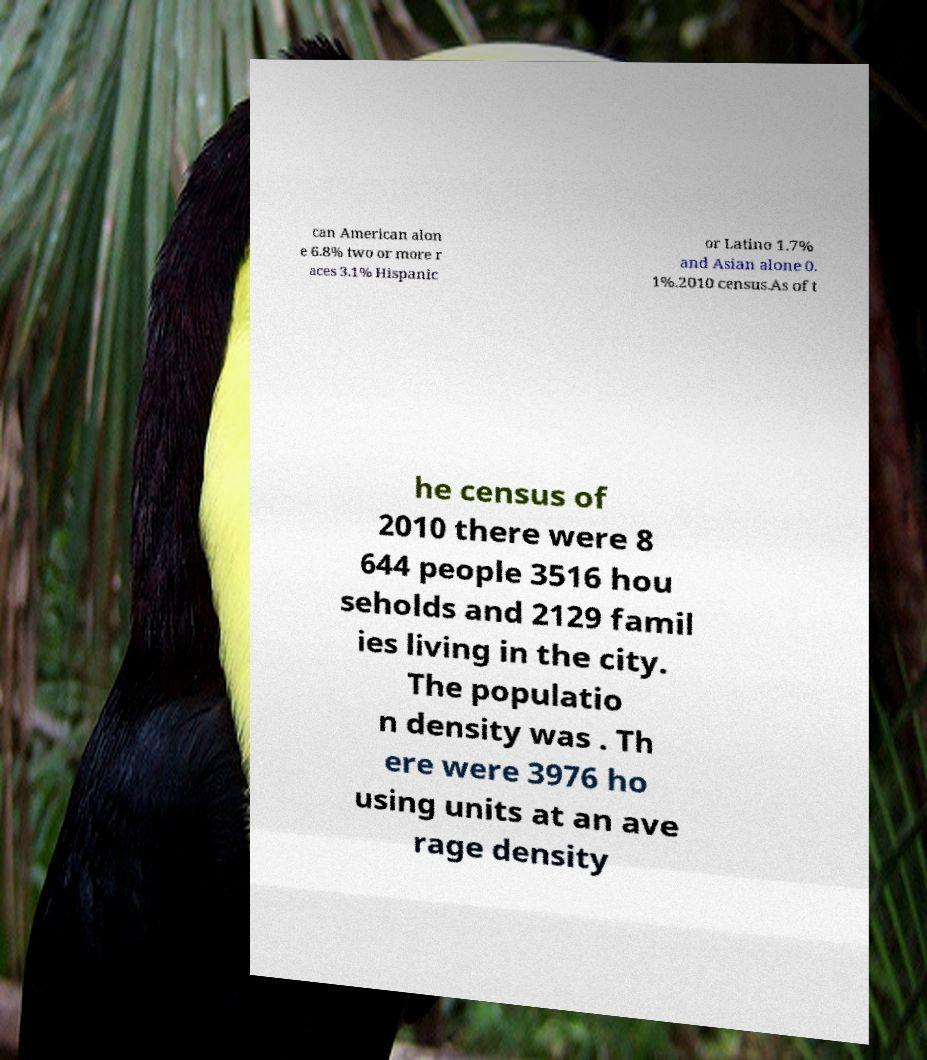Could you extract and type out the text from this image? can American alon e 6.8% two or more r aces 3.1% Hispanic or Latino 1.7% and Asian alone 0. 1%.2010 census.As of t he census of 2010 there were 8 644 people 3516 hou seholds and 2129 famil ies living in the city. The populatio n density was . Th ere were 3976 ho using units at an ave rage density 